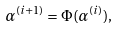Convert formula to latex. <formula><loc_0><loc_0><loc_500><loc_500>\alpha ^ { ( i + 1 ) } = \Phi ( \alpha ^ { ( i ) } ) ,</formula> 